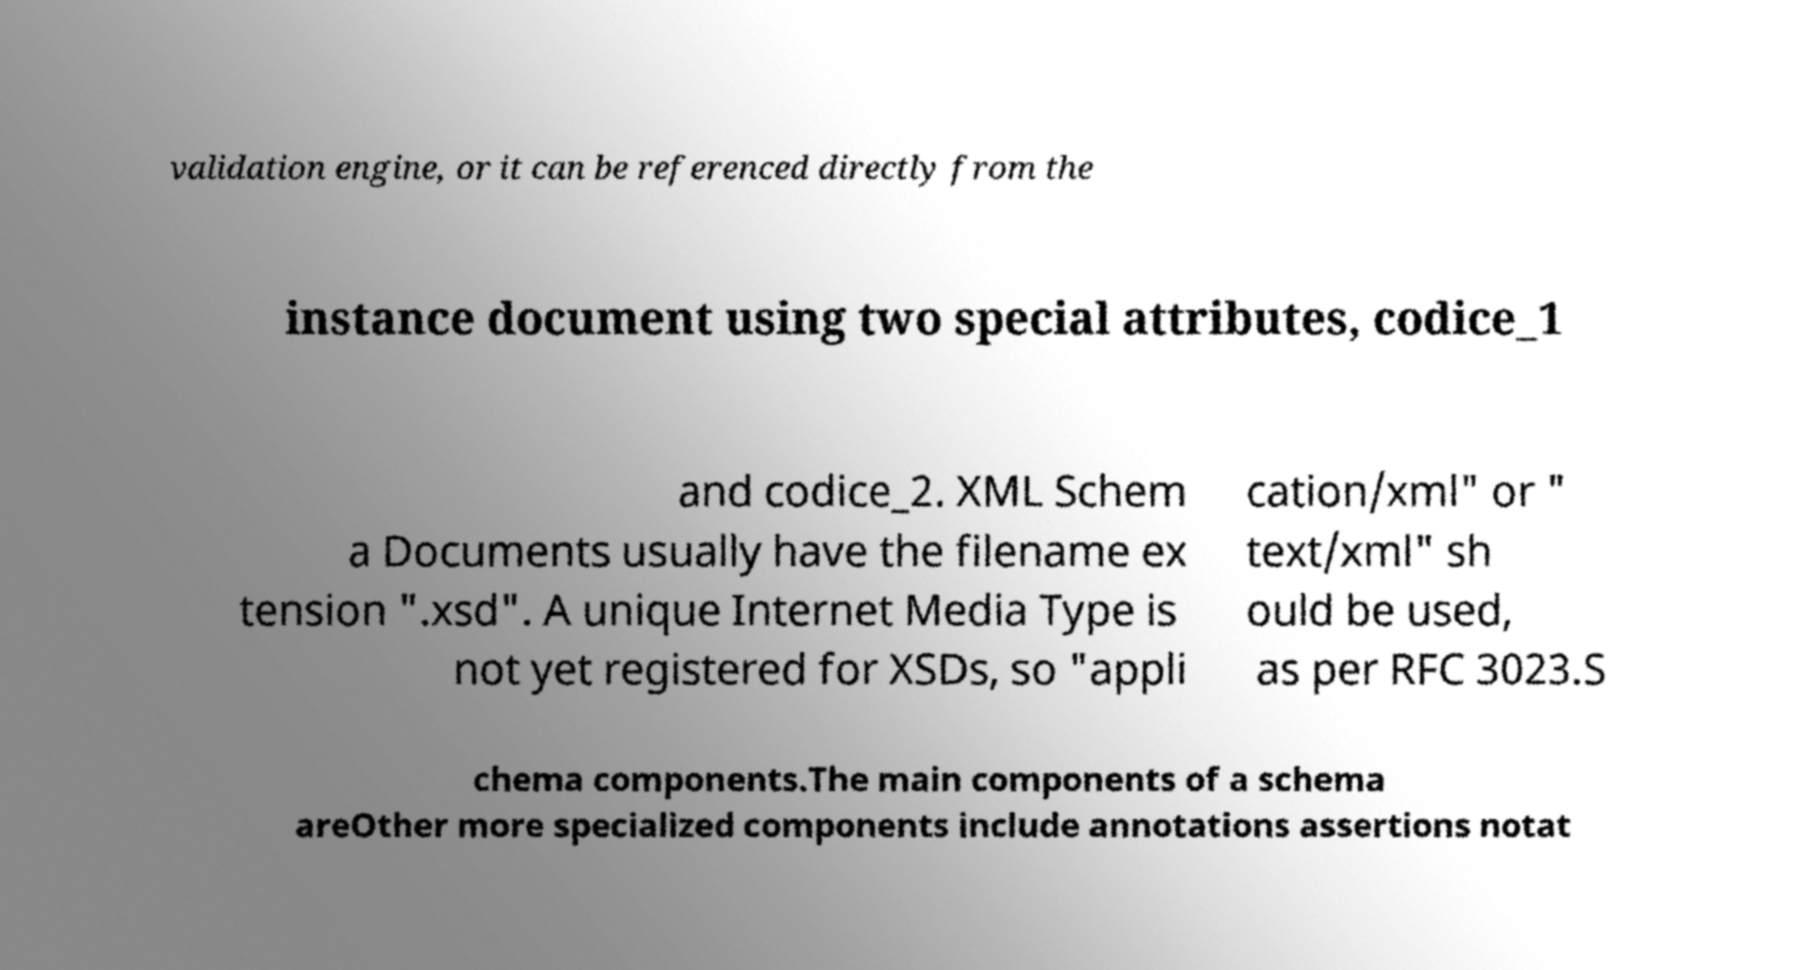Please read and relay the text visible in this image. What does it say? validation engine, or it can be referenced directly from the instance document using two special attributes, codice_1 and codice_2. XML Schem a Documents usually have the filename ex tension ".xsd". A unique Internet Media Type is not yet registered for XSDs, so "appli cation/xml" or " text/xml" sh ould be used, as per RFC 3023.S chema components.The main components of a schema areOther more specialized components include annotations assertions notat 